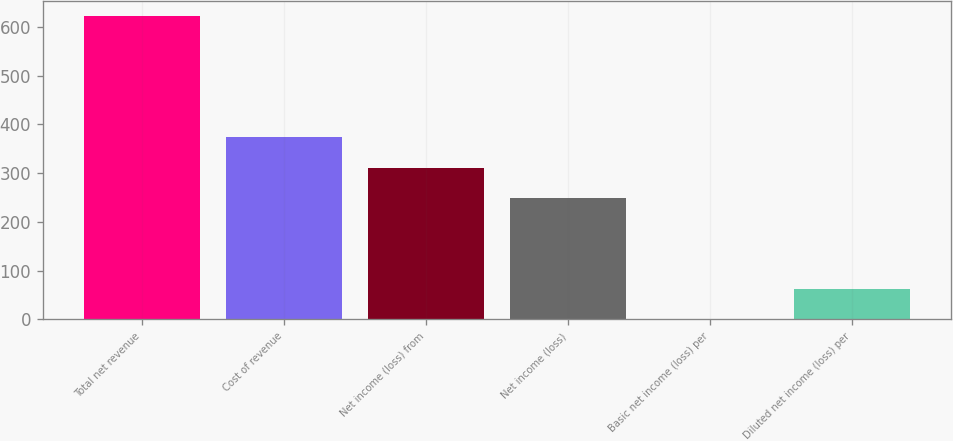Convert chart to OTSL. <chart><loc_0><loc_0><loc_500><loc_500><bar_chart><fcel>Total net revenue<fcel>Cost of revenue<fcel>Net income (loss) from<fcel>Net income (loss)<fcel>Basic net income (loss) per<fcel>Diluted net income (loss) per<nl><fcel>622<fcel>373.24<fcel>311.04<fcel>248.84<fcel>0.04<fcel>62.24<nl></chart> 